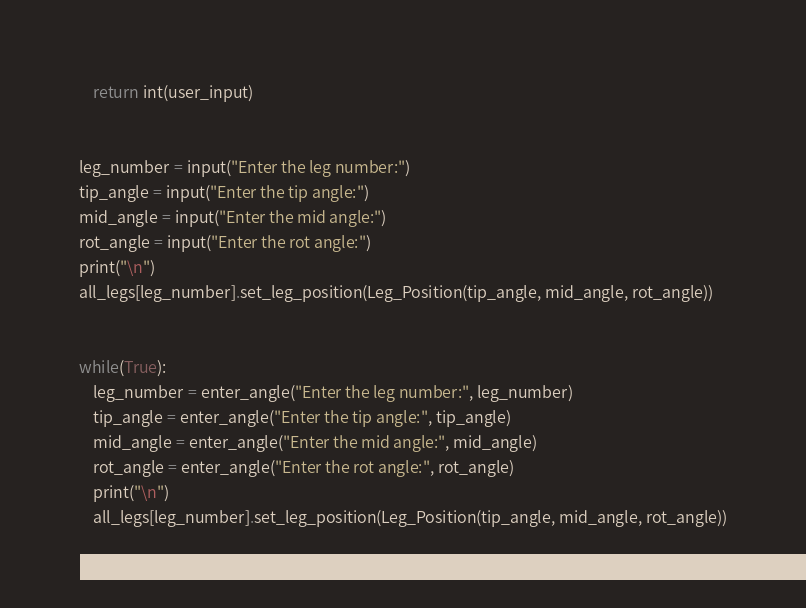Convert code to text. <code><loc_0><loc_0><loc_500><loc_500><_Python_>
    return int(user_input)


leg_number = input("Enter the leg number:")
tip_angle = input("Enter the tip angle:")
mid_angle = input("Enter the mid angle:")
rot_angle = input("Enter the rot angle:")
print("\n")
all_legs[leg_number].set_leg_position(Leg_Position(tip_angle, mid_angle, rot_angle))


while(True):
    leg_number = enter_angle("Enter the leg number:", leg_number)
    tip_angle = enter_angle("Enter the tip angle:", tip_angle)
    mid_angle = enter_angle("Enter the mid angle:", mid_angle)
    rot_angle = enter_angle("Enter the rot angle:", rot_angle)
    print("\n")
    all_legs[leg_number].set_leg_position(Leg_Position(tip_angle, mid_angle, rot_angle))

</code> 